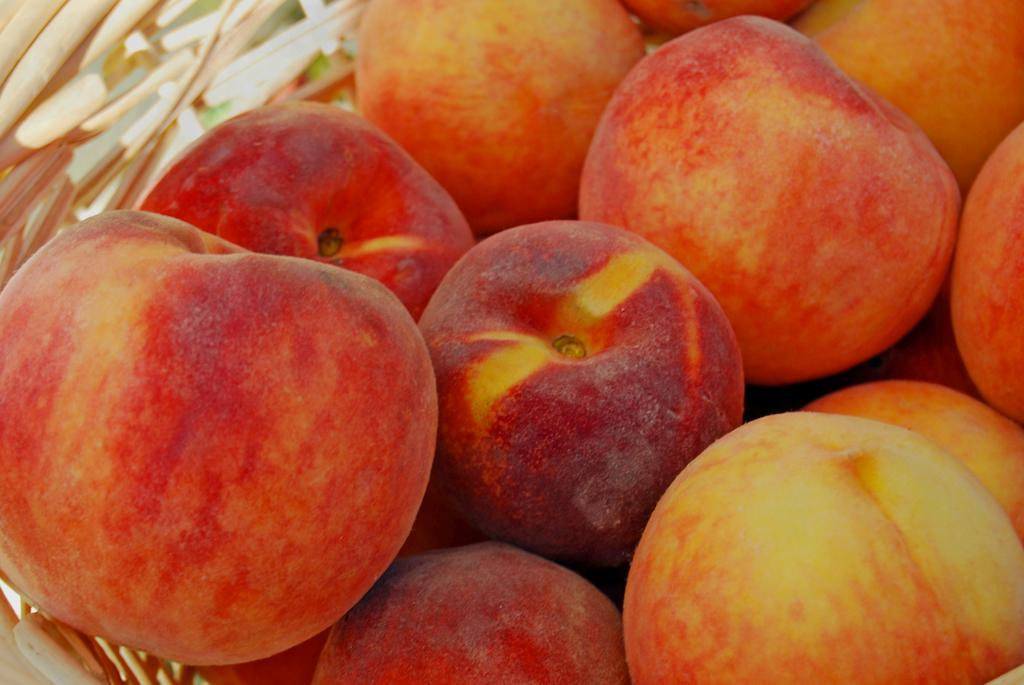What type of fruit is present in the image? There are apples in the image. What colors can be seen on the apples? The apples are in red and yellow colors. In what type of container are the apples placed? The apples are in a wooden bowl. How does the feeling of excitement manifest itself in the image? There is no indication of any feelings or emotions in the image, as it only features apples in a wooden bowl. 